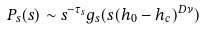Convert formula to latex. <formula><loc_0><loc_0><loc_500><loc_500>P _ { s } ( s ) \sim s ^ { - \tau _ { s } } g _ { s } ( s ( h _ { 0 } - h _ { c } ) ^ { D \nu } )</formula> 